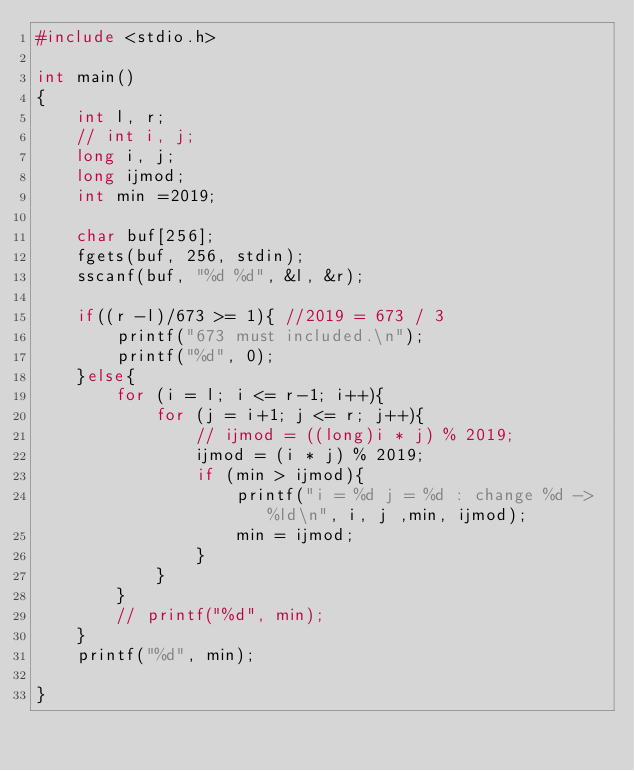<code> <loc_0><loc_0><loc_500><loc_500><_C_>#include <stdio.h>

int main()
{
    int l, r;
    // int i, j;
    long i, j;
    long ijmod;
    int min =2019;

    char buf[256];
    fgets(buf, 256, stdin);
    sscanf(buf, "%d %d", &l, &r);

    if((r -l)/673 >= 1){ //2019 = 673 / 3
        printf("673 must included.\n");
        printf("%d", 0);
    }else{
        for (i = l; i <= r-1; i++){
            for (j = i+1; j <= r; j++){
                // ijmod = ((long)i * j) % 2019;
                ijmod = (i * j) % 2019;
                if (min > ijmod){
                    printf("i = %d j = %d : change %d -> %ld\n", i, j ,min, ijmod);
                    min = ijmod;
                }
            }
        }
        // printf("%d", min);
    }
    printf("%d", min);

}</code> 